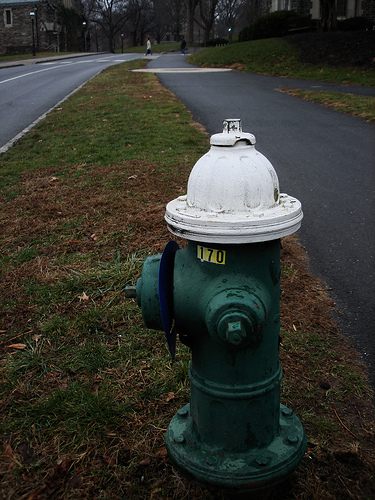What does the number '170' on the fire hydrant signify? The number '170' on the fire hydrant likely serves as an identification marker, which helps water management services and emergency responders locate and reference the hydrant quickly. Could there be any historical significance to these fixtures? Indeed, fire hydrants have evolved significantly over the years and can often tell part of the history of a town’s development and infrastructure. They are essential for providing immediate water access during fires and can sometimes be antique or commemorative. 